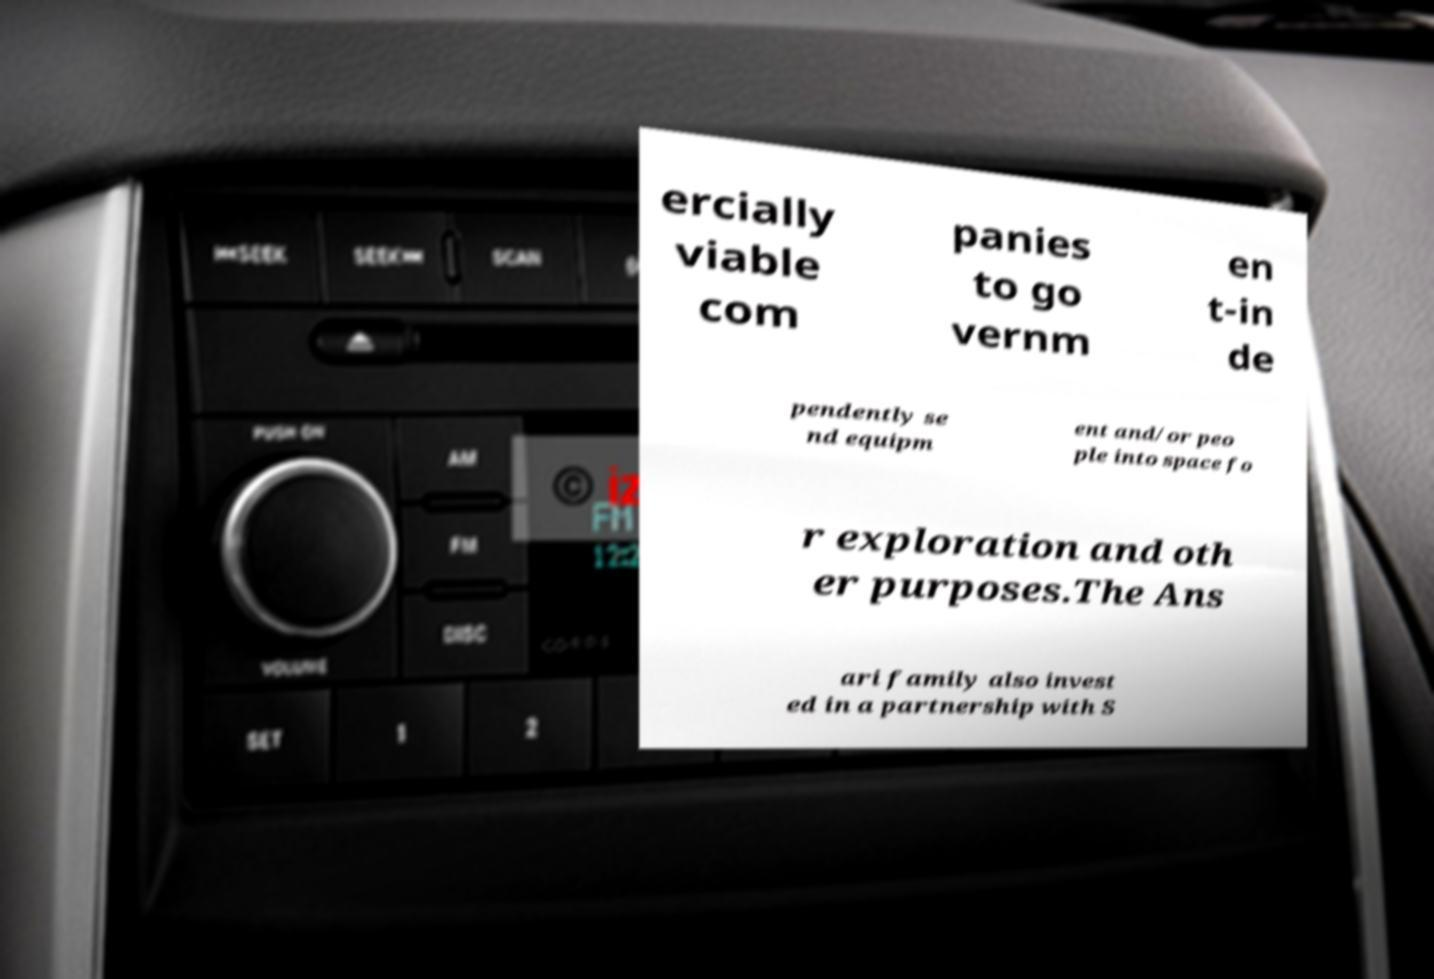Please identify and transcribe the text found in this image. ercially viable com panies to go vernm en t-in de pendently se nd equipm ent and/or peo ple into space fo r exploration and oth er purposes.The Ans ari family also invest ed in a partnership with S 